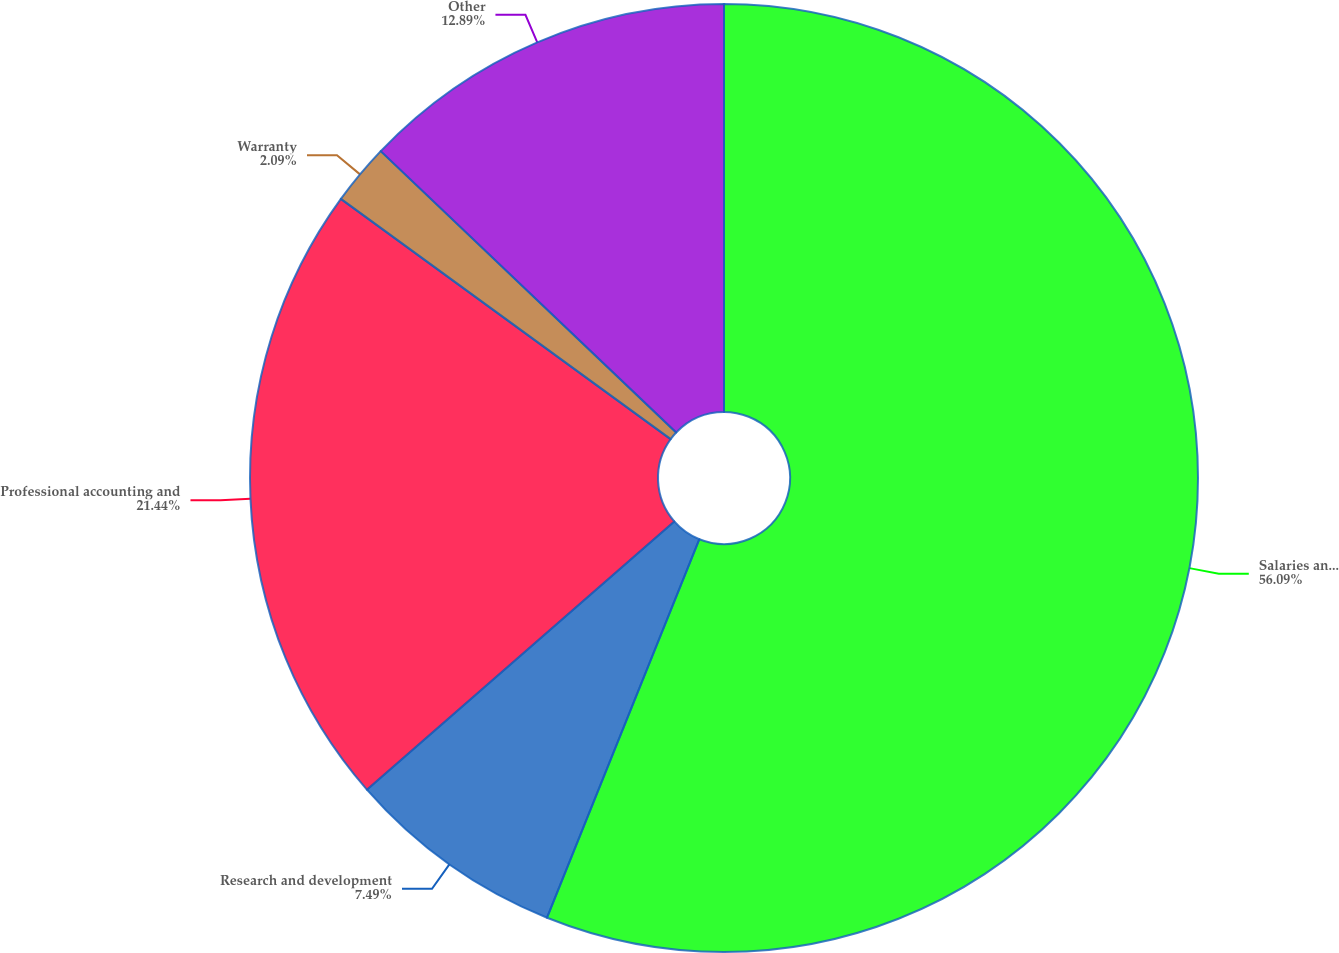Convert chart to OTSL. <chart><loc_0><loc_0><loc_500><loc_500><pie_chart><fcel>Salaries and benefits<fcel>Research and development<fcel>Professional accounting and<fcel>Warranty<fcel>Other<nl><fcel>56.09%<fcel>7.49%<fcel>21.44%<fcel>2.09%<fcel>12.89%<nl></chart> 